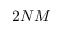Convert formula to latex. <formula><loc_0><loc_0><loc_500><loc_500>2 N M</formula> 